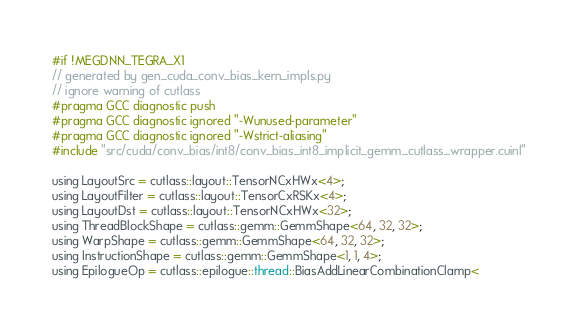Convert code to text. <code><loc_0><loc_0><loc_500><loc_500><_Cuda_>#if !MEGDNN_TEGRA_X1
// generated by gen_cuda_conv_bias_kern_impls.py
// ignore warning of cutlass
#pragma GCC diagnostic push
#pragma GCC diagnostic ignored "-Wunused-parameter"
#pragma GCC diagnostic ignored "-Wstrict-aliasing"
#include "src/cuda/conv_bias/int8/conv_bias_int8_implicit_gemm_cutlass_wrapper.cuinl"

using LayoutSrc = cutlass::layout::TensorNCxHWx<4>;
using LayoutFilter = cutlass::layout::TensorCxRSKx<4>;
using LayoutDst = cutlass::layout::TensorNCxHWx<32>;
using ThreadBlockShape = cutlass::gemm::GemmShape<64, 32, 32>;
using WarpShape = cutlass::gemm::GemmShape<64, 32, 32>;
using InstructionShape = cutlass::gemm::GemmShape<1, 1, 4>;
using EpilogueOp = cutlass::epilogue::thread::BiasAddLinearCombinationClamp<</code> 